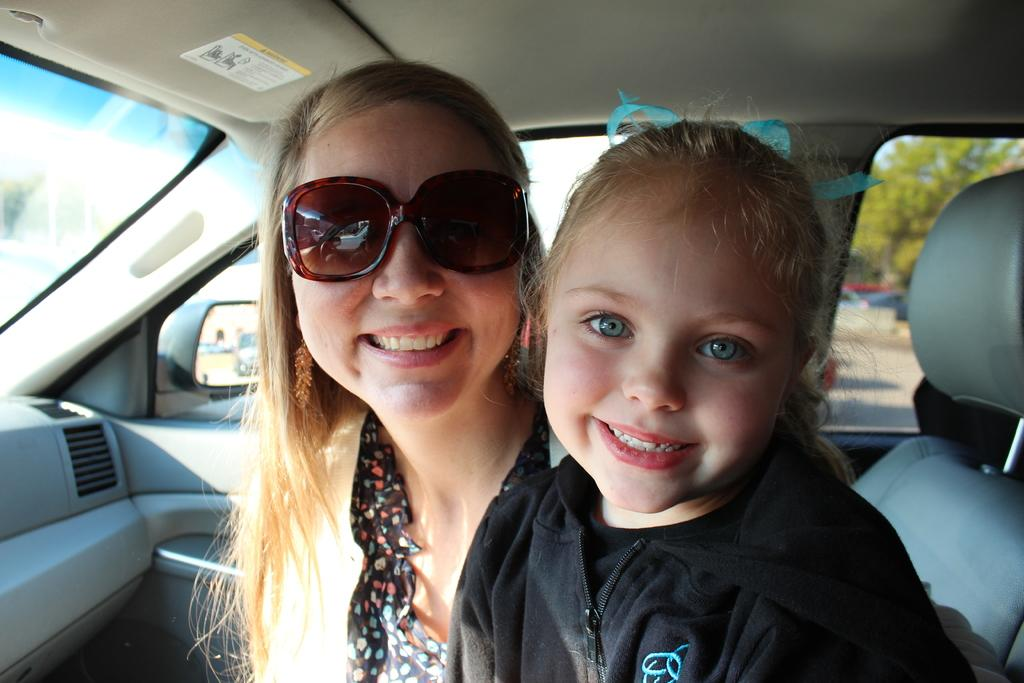How many people are in the image? There are two persons in the image. What are the two persons doing in the image? The two persons are sitting in a car. Can you describe any specific detail about one of the persons? One of the persons is wearing spectacles. What type of grass can be seen growing on the table in the image? There is no grass or table present in the image; it features two persons sitting in a car. 